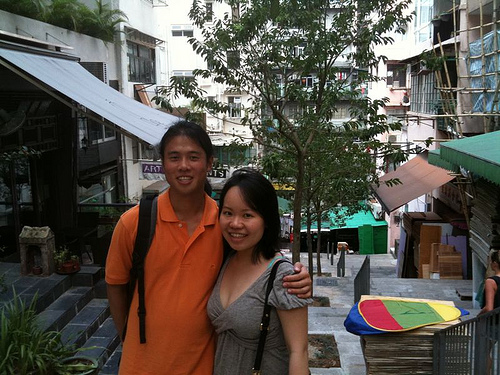<image>
Is there a lady on the man? No. The lady is not positioned on the man. They may be near each other, but the lady is not supported by or resting on top of the man. 